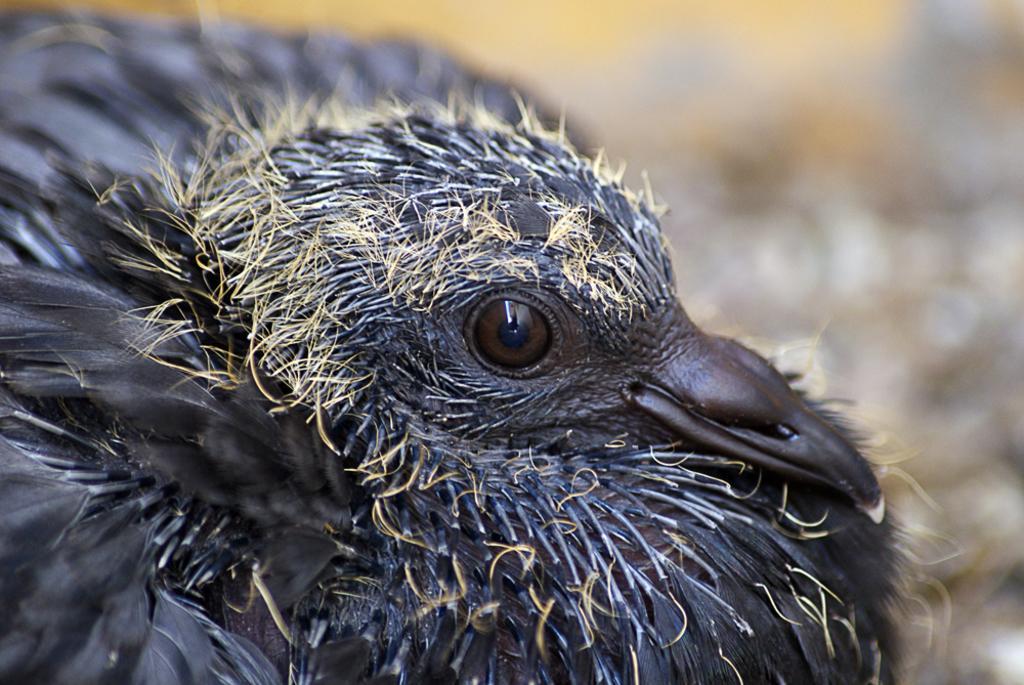Describe this image in one or two sentences. In this image I can see a black colour bird in the front. I can also see this image is blurry in the background. 